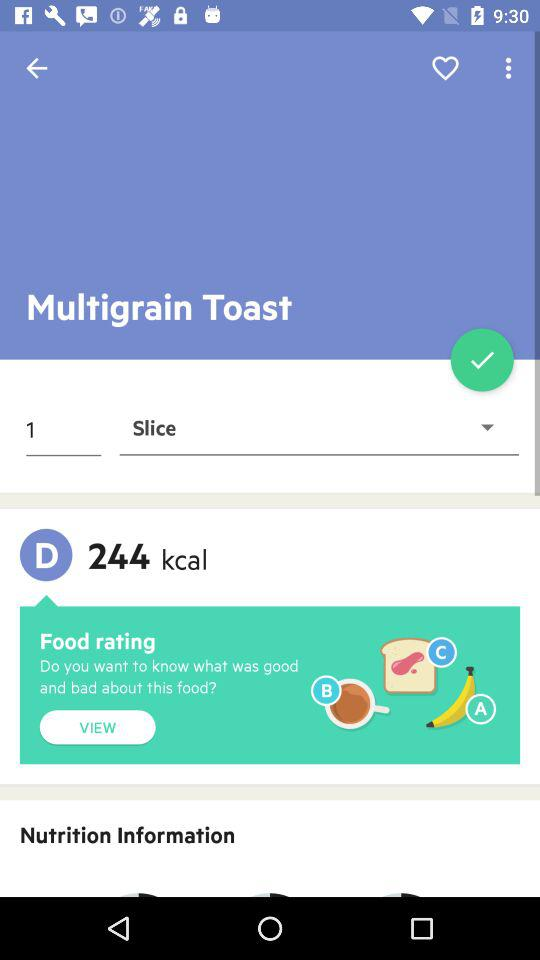How many servings are there in the food?
Answer the question using a single word or phrase. 1 